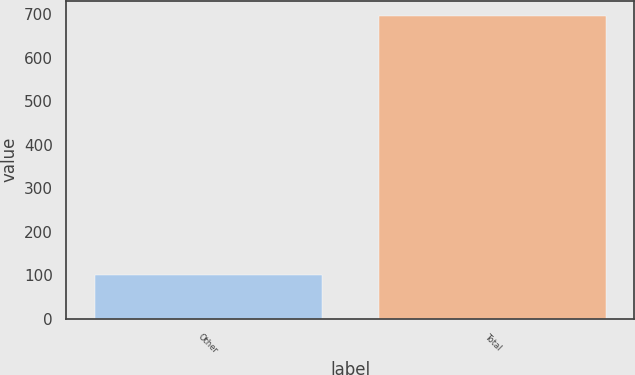Convert chart to OTSL. <chart><loc_0><loc_0><loc_500><loc_500><bar_chart><fcel>Other<fcel>Total<nl><fcel>101<fcel>697<nl></chart> 